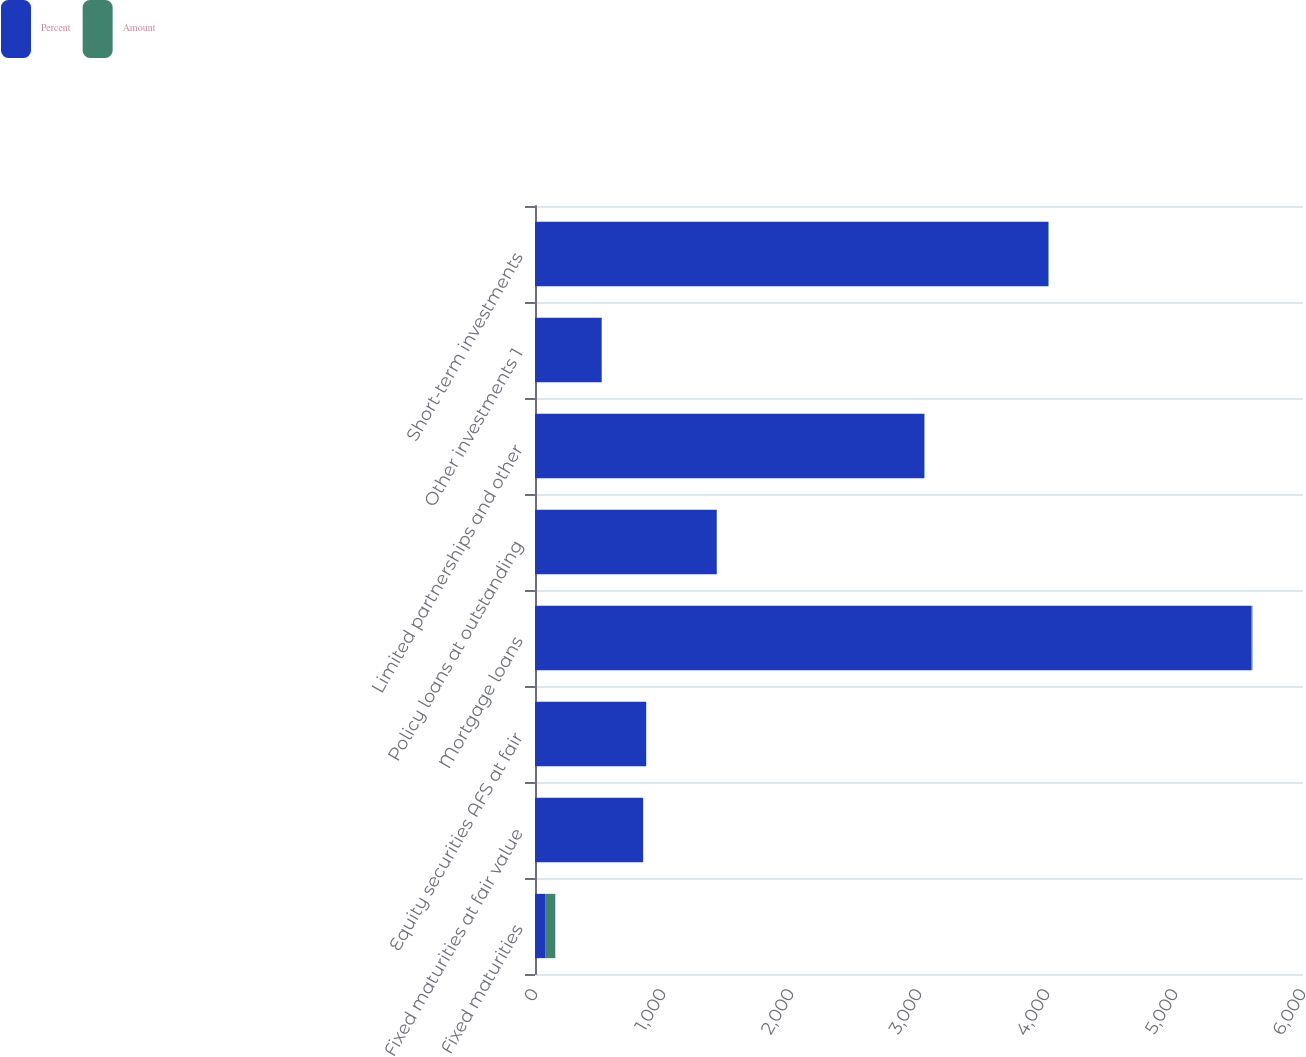<chart> <loc_0><loc_0><loc_500><loc_500><stacked_bar_chart><ecel><fcel>Fixed maturities<fcel>Fixed maturities at fair value<fcel>Equity securities AFS at fair<fcel>Mortgage loans<fcel>Policy loans at outstanding<fcel>Limited partnerships and other<fcel>Other investments 1<fcel>Short-term investments<nl><fcel>Percent<fcel>79.2<fcel>844<fcel>868<fcel>5598<fcel>1420<fcel>3040<fcel>521<fcel>4008<nl><fcel>Amount<fcel>79.2<fcel>1.1<fcel>1.1<fcel>7.1<fcel>1.8<fcel>3.9<fcel>0.7<fcel>5.1<nl></chart> 